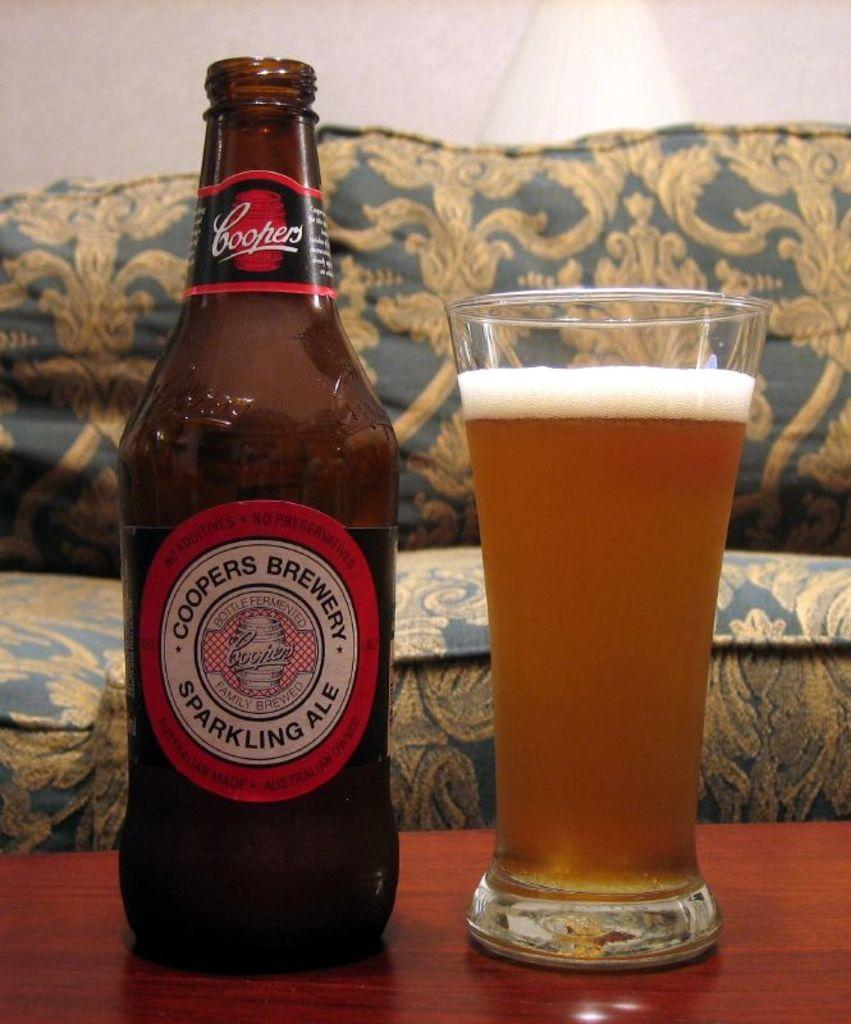<image>
Describe the image concisely. a bottle of sparkling ale poured in a cup next to the bottle. 